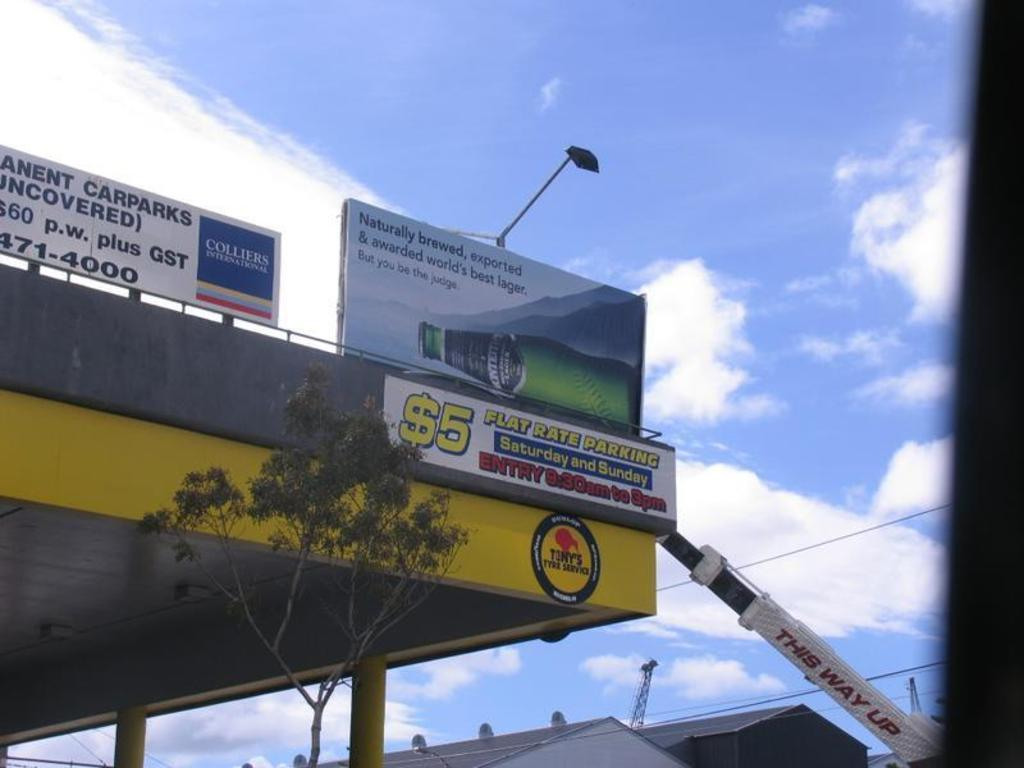Provide a one-sentence caption for the provided image. One can park there car here for $5 on Saturdays and Sundays. 